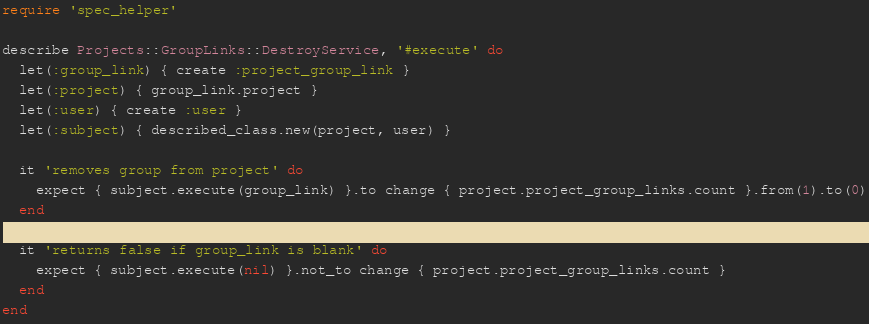<code> <loc_0><loc_0><loc_500><loc_500><_Ruby_>require 'spec_helper'

describe Projects::GroupLinks::DestroyService, '#execute' do
  let(:group_link) { create :project_group_link }
  let(:project) { group_link.project }
  let(:user) { create :user }
  let(:subject) { described_class.new(project, user) }

  it 'removes group from project' do
    expect { subject.execute(group_link) }.to change { project.project_group_links.count }.from(1).to(0)
  end

  it 'returns false if group_link is blank' do
    expect { subject.execute(nil) }.not_to change { project.project_group_links.count }
  end
end
</code> 